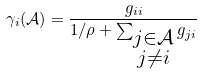Convert formula to latex. <formula><loc_0><loc_0><loc_500><loc_500>\gamma _ { i } ( \mathcal { A } ) = \frac { g _ { i i } } { 1 / \rho + \sum _ { \substack { j \in \mathcal { A } \\ j \neq i } } g _ { j i } }</formula> 